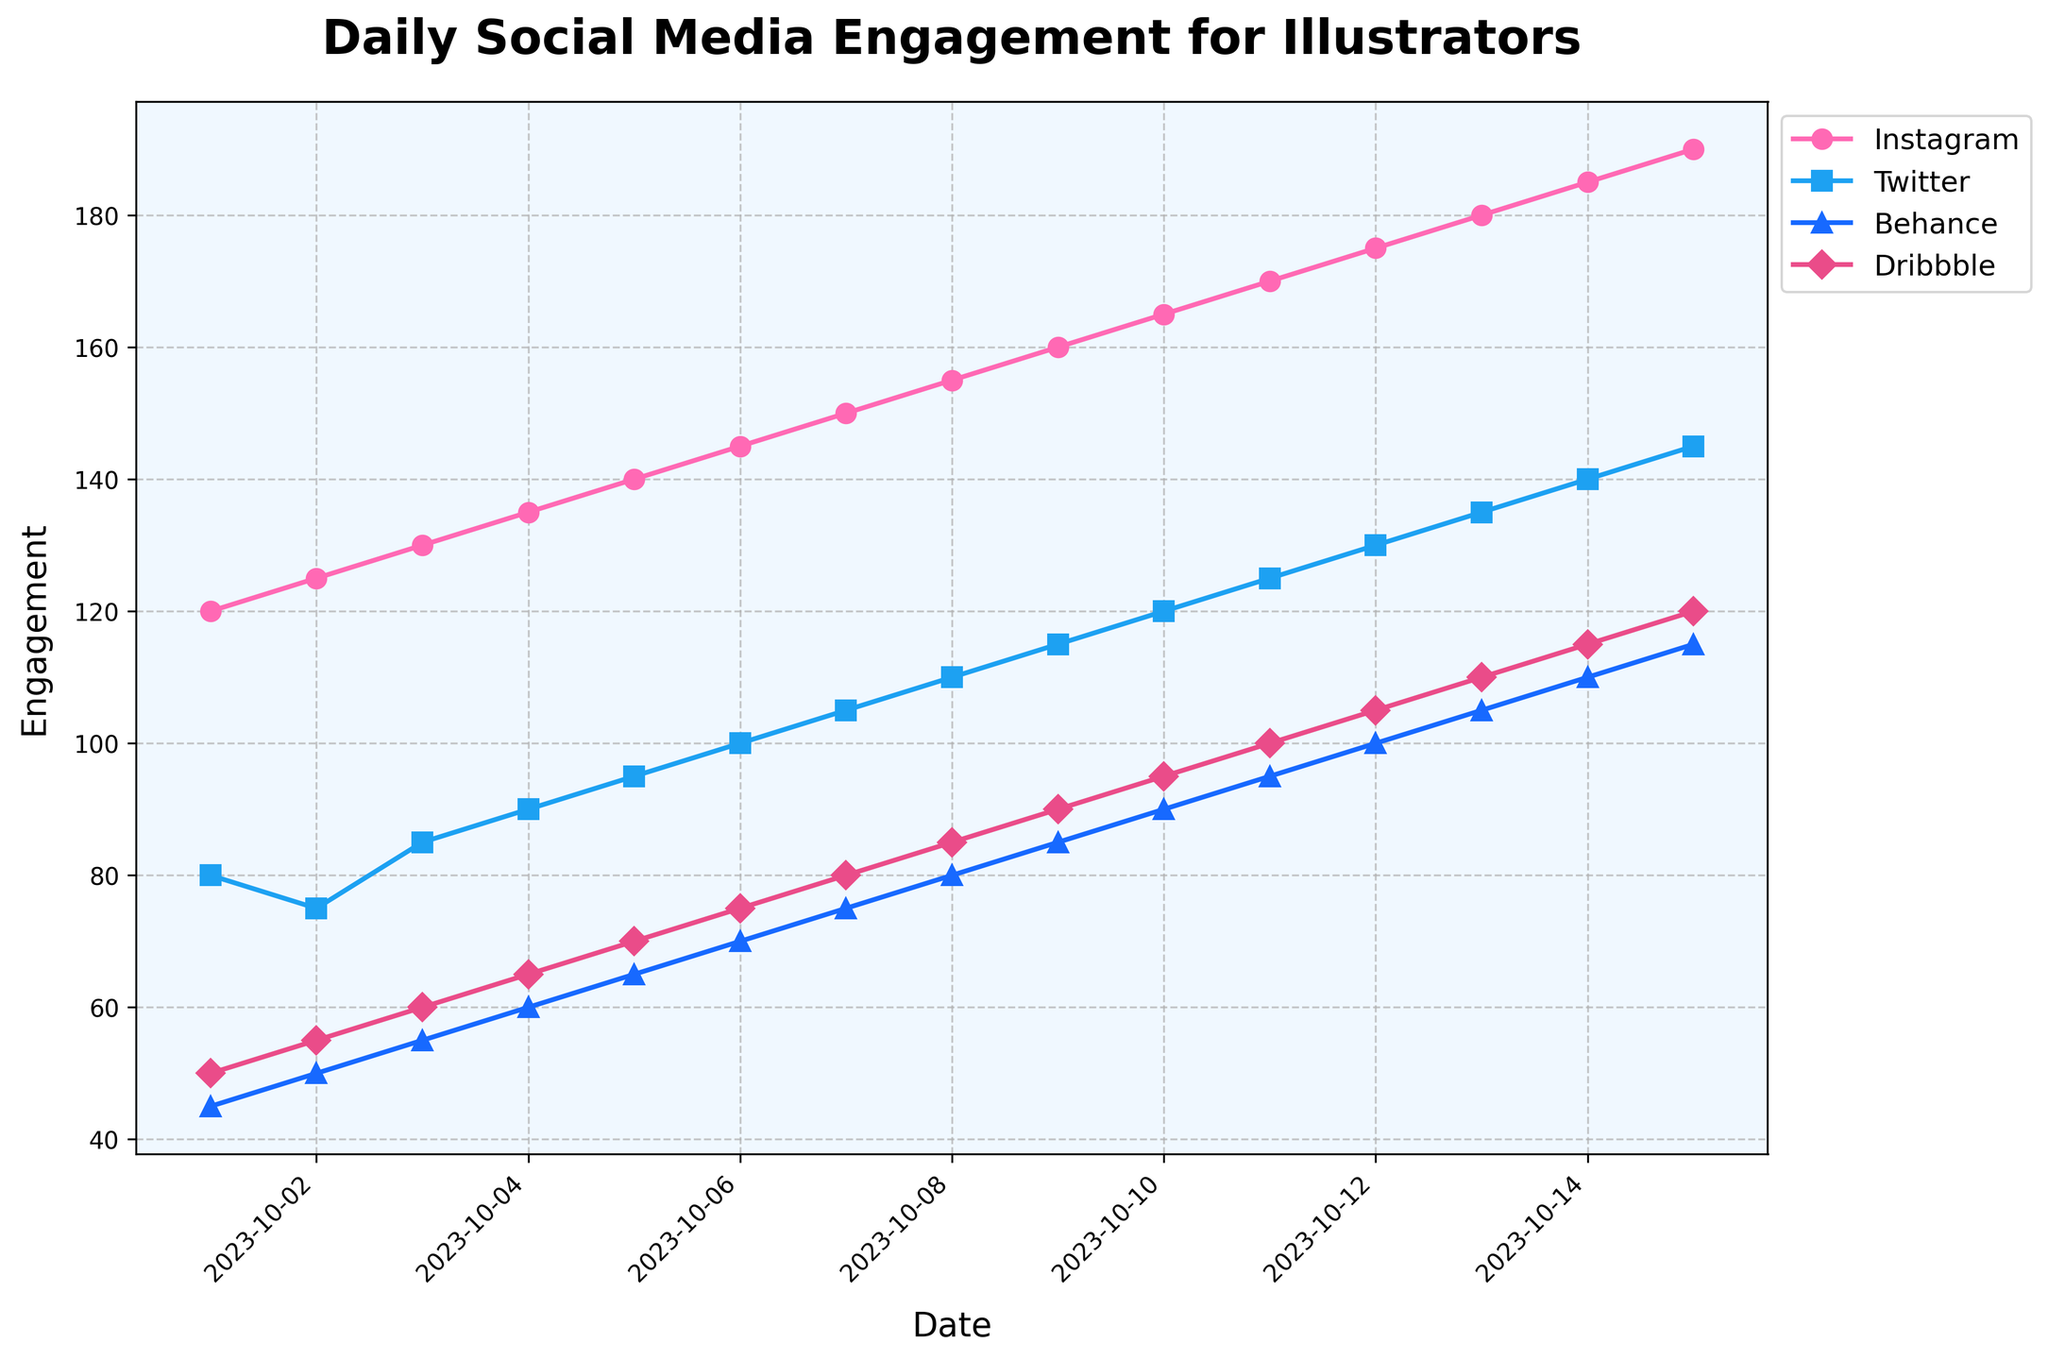What is the title of the figure? The title is prominently displayed at the top of the figure. It reads "Daily Social Media Engagement for Illustrators".
Answer: Daily Social Media Engagement for Illustrators Which social media platform has the highest engagement on October 11, 2023? By looking at the data points on October 11, 2023, Instagram shows the highest engagement value.
Answer: Instagram What color is used to represent Twitter in the figure? Twitter is represented by a blue-colored line which is indicated in the legend.
Answer: Blue On which date does Behance first reach an engagement value of 100? By tracing the line representing Behance, the engagement first reaches 100 on October 12, 2023.
Answer: October 12, 2023 Between October 1st and October 15th, 2023, on which date does Instagram's engagement surpass 150 for the first time? By following the Instagram plot line, the engagement first surpasses 150 on October 7, 2023.
Answer: October 7, 2023 How does Twitter's engagement on October 15, 2023, compare to its engagement on October 1, 2023? Comparing the data points for Twitter: on October 1, 2023, the value is 80, and on October 15, 2023, it is 145. The latter is higher.
Answer: Higher Which platform shows the slowest rate of increase in engagement over the observed period? By observing the slopes of the lines, Behance shows the slowest increase in engagement as its line is the flattest among all.
Answer: Behance What is the average engagement for Dribbble between October 1 and October 15, 2023? Sum the engagement values for Dribbble from October 1 to October 15 and divide by the number of days. Sum = 50+55+60+65+70+75+80+85+90+95+100+105+110+115+120 = 1375. Average = 1375/15 = 91.67.
Answer: 91.67 Which two platforms have the closest engagement values on October 5, 2023? On October 5, 2023, Twitter has an engagement of 95 and Dribbble has 70. Instagram has 140, and Behance has 65. Dribbble and Behance are closest with 70 and 65 respectively.
Answer: Dribbble and Behance What’s the difference in engagement between Instagram and Twitter on October 10, 2023? On October 10, Instagram has an engagement of 165 and Twitter has 120. The difference is 165 - 120 = 45.
Answer: 45 